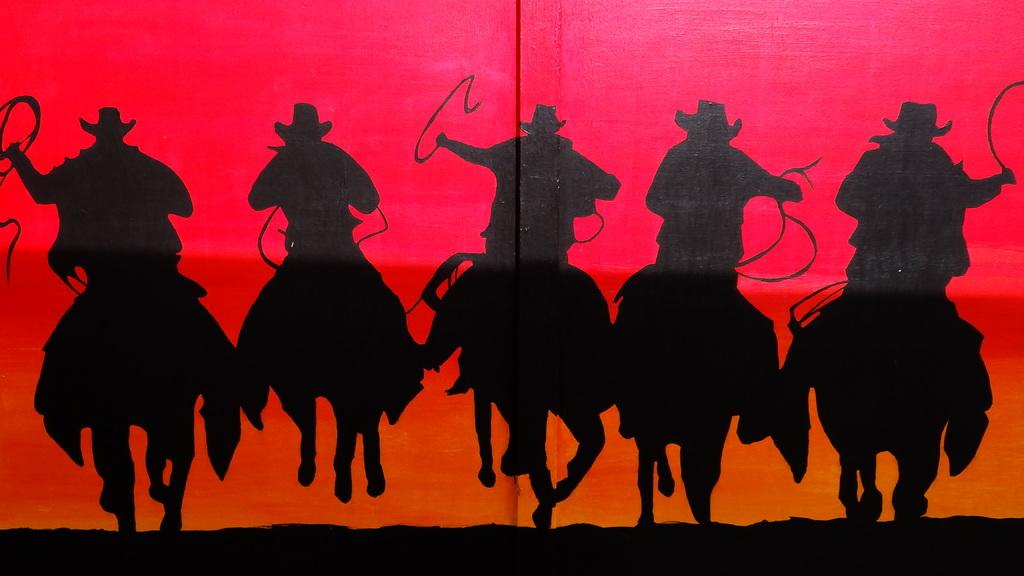What is the color of the painting in the image? The image is a black painting. How many people are depicted in the painting? There are five persons in the painting. What are the persons doing in the painting? The persons are riding horses. What accessories are the persons wearing in the painting? The persons are wearing caps on their heads. What objects are the persons holding in the painting? The persons are holding whips in their hands. How many spiders can be seen crawling on the persons in the painting? There are no spiders visible in the painting; the persons are riding horses and holding whips. What act are the persons performing in the painting? The painting does not depict a specific act or performance; it simply shows five persons riding horses while wearing caps and holding whips. 